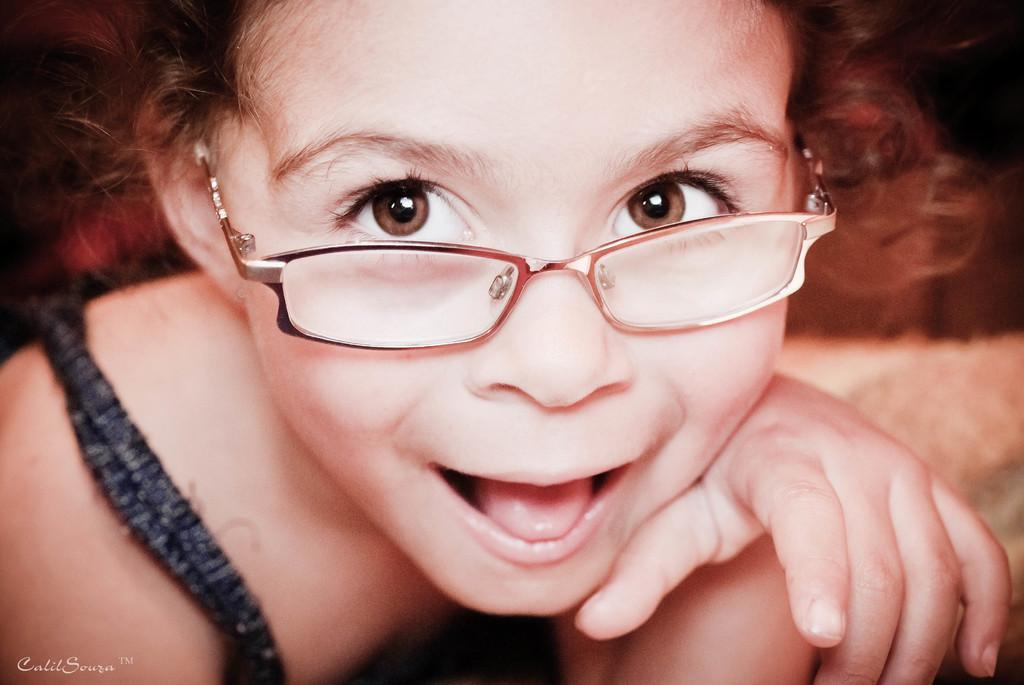Who is the main subject in the image? There is a girl in the image. What is the girl wearing? The girl is wearing spectacles. What is the girl's expression in the image? The girl is smiling. Can you describe the watermark in the image? There is a watermark on the bottom left side of the image. How would you describe the background of the image? The background of the image is blurred. What type of honey is being used by the girl in the image? There is no honey present in the image; the girl is wearing spectacles and smiling. What is the girl's hope for the future in the image? The image does not provide any information about the girl's hopes for the future. 